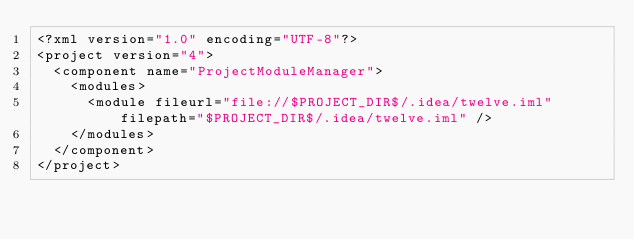Convert code to text. <code><loc_0><loc_0><loc_500><loc_500><_XML_><?xml version="1.0" encoding="UTF-8"?>
<project version="4">
  <component name="ProjectModuleManager">
    <modules>
      <module fileurl="file://$PROJECT_DIR$/.idea/twelve.iml" filepath="$PROJECT_DIR$/.idea/twelve.iml" />
    </modules>
  </component>
</project></code> 